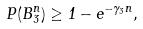<formula> <loc_0><loc_0><loc_500><loc_500>P ( B ^ { n } _ { 3 } ) \geq 1 - e ^ { - \gamma _ { 3 } n } ,</formula> 